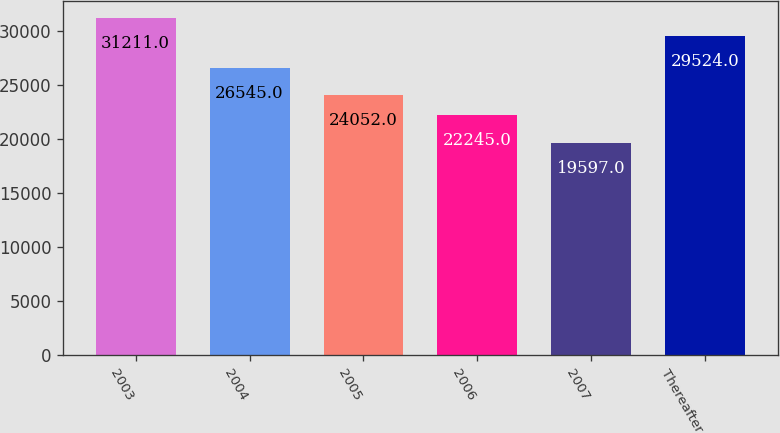Convert chart to OTSL. <chart><loc_0><loc_0><loc_500><loc_500><bar_chart><fcel>2003<fcel>2004<fcel>2005<fcel>2006<fcel>2007<fcel>Thereafter<nl><fcel>31211<fcel>26545<fcel>24052<fcel>22245<fcel>19597<fcel>29524<nl></chart> 